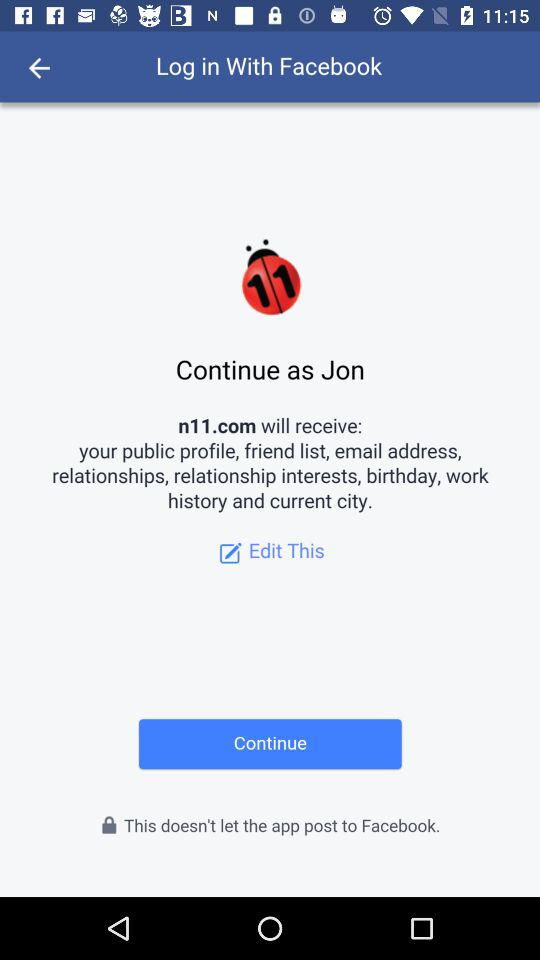What is the user name? The user name is Jon. 